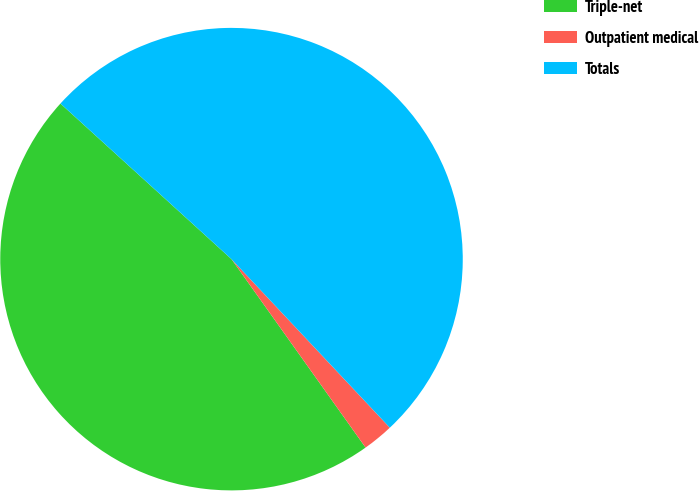Convert chart. <chart><loc_0><loc_0><loc_500><loc_500><pie_chart><fcel>Triple-net<fcel>Outpatient medical<fcel>Totals<nl><fcel>46.59%<fcel>2.16%<fcel>51.25%<nl></chart> 